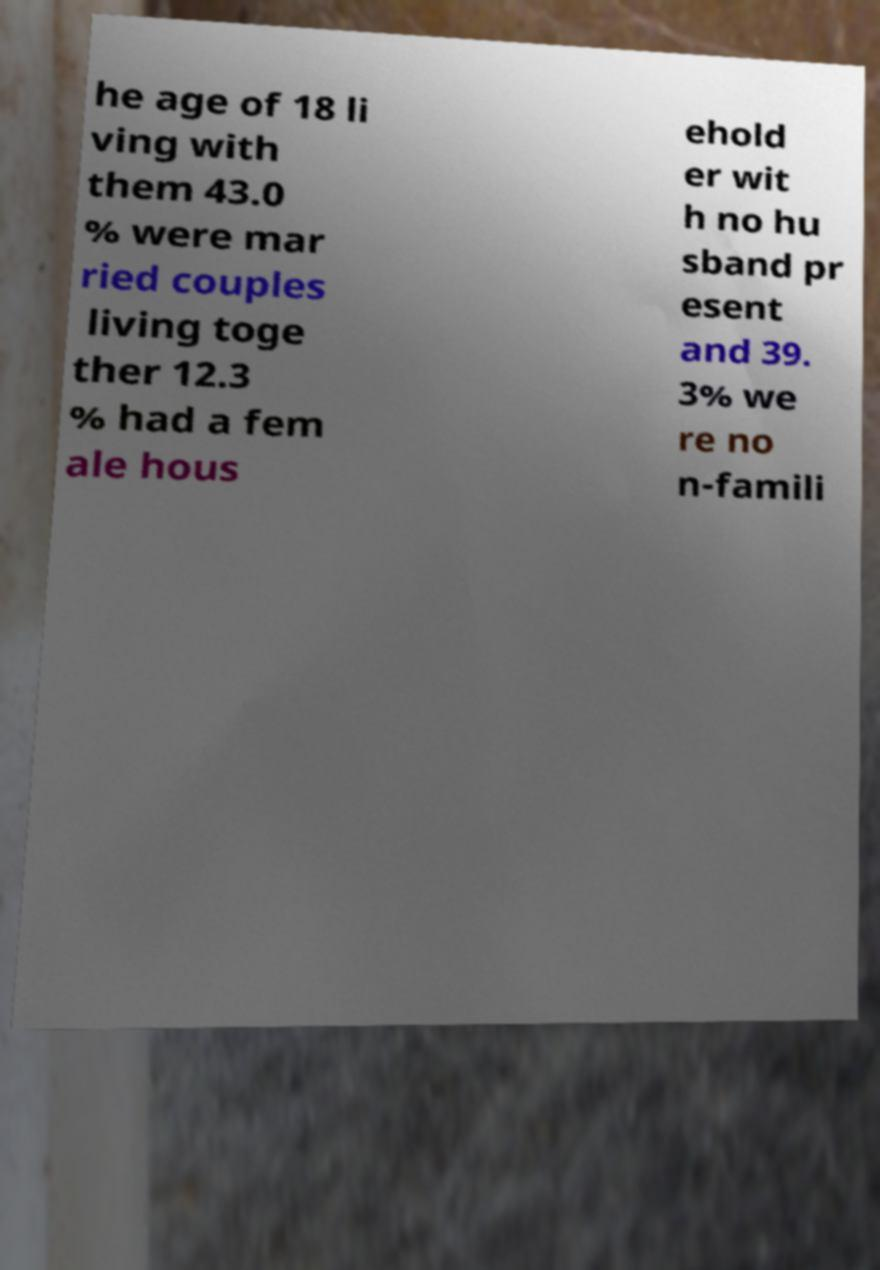There's text embedded in this image that I need extracted. Can you transcribe it verbatim? he age of 18 li ving with them 43.0 % were mar ried couples living toge ther 12.3 % had a fem ale hous ehold er wit h no hu sband pr esent and 39. 3% we re no n-famili 